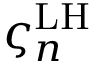Convert formula to latex. <formula><loc_0><loc_0><loc_500><loc_500>\varsigma _ { n } ^ { L H }</formula> 